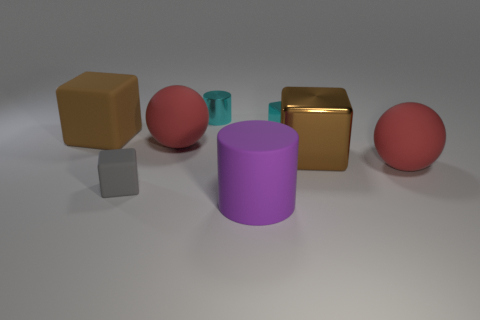There is a matte cylinder; what number of cyan metal cylinders are on the right side of it?
Offer a terse response. 0. What is the shape of the tiny metal thing that is the same color as the small cylinder?
Your answer should be very brief. Cube. Is there a small cyan thing that is on the right side of the tiny object that is in front of the matte thing that is to the right of the small cyan block?
Provide a succinct answer. Yes. Do the cyan cylinder and the purple matte object have the same size?
Ensure brevity in your answer.  No. Are there an equal number of large matte cubes in front of the large rubber cube and metal objects on the left side of the brown shiny block?
Your answer should be compact. No. There is a tiny cyan shiny thing right of the cyan metal cylinder; what shape is it?
Keep it short and to the point. Cube. The cyan object that is the same size as the cyan cylinder is what shape?
Provide a succinct answer. Cube. What is the color of the small cube that is behind the large red ball that is right of the cylinder behind the gray matte cube?
Ensure brevity in your answer.  Cyan. Does the small gray thing have the same shape as the brown metallic thing?
Your answer should be very brief. Yes. Are there the same number of metallic things in front of the brown metal thing and red rubber spheres?
Ensure brevity in your answer.  No. 